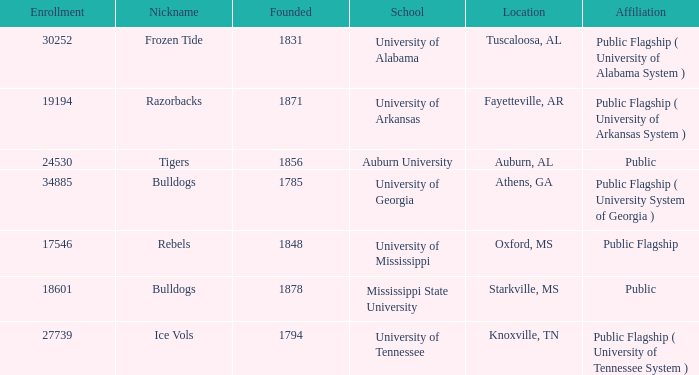What is the maximum enrollment of the schools? 34885.0. Can you parse all the data within this table? {'header': ['Enrollment', 'Nickname', 'Founded', 'School', 'Location', 'Affiliation'], 'rows': [['30252', 'Frozen Tide', '1831', 'University of Alabama', 'Tuscaloosa, AL', 'Public Flagship ( University of Alabama System )'], ['19194', 'Razorbacks', '1871', 'University of Arkansas', 'Fayetteville, AR', 'Public Flagship ( University of Arkansas System )'], ['24530', 'Tigers', '1856', 'Auburn University', 'Auburn, AL', 'Public'], ['34885', 'Bulldogs', '1785', 'University of Georgia', 'Athens, GA', 'Public Flagship ( University System of Georgia )'], ['17546', 'Rebels', '1848', 'University of Mississippi', 'Oxford, MS', 'Public Flagship'], ['18601', 'Bulldogs', '1878', 'Mississippi State University', 'Starkville, MS', 'Public'], ['27739', 'Ice Vols', '1794', 'University of Tennessee', 'Knoxville, TN', 'Public Flagship ( University of Tennessee System )']]} 